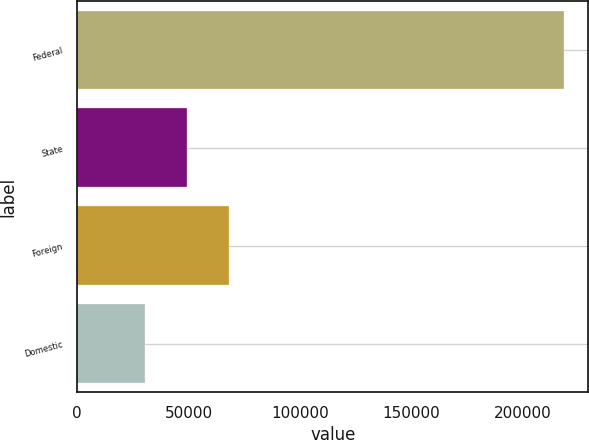<chart> <loc_0><loc_0><loc_500><loc_500><bar_chart><fcel>Federal<fcel>State<fcel>Foreign<fcel>Domestic<nl><fcel>218302<fcel>49427.8<fcel>68191.6<fcel>30664<nl></chart> 